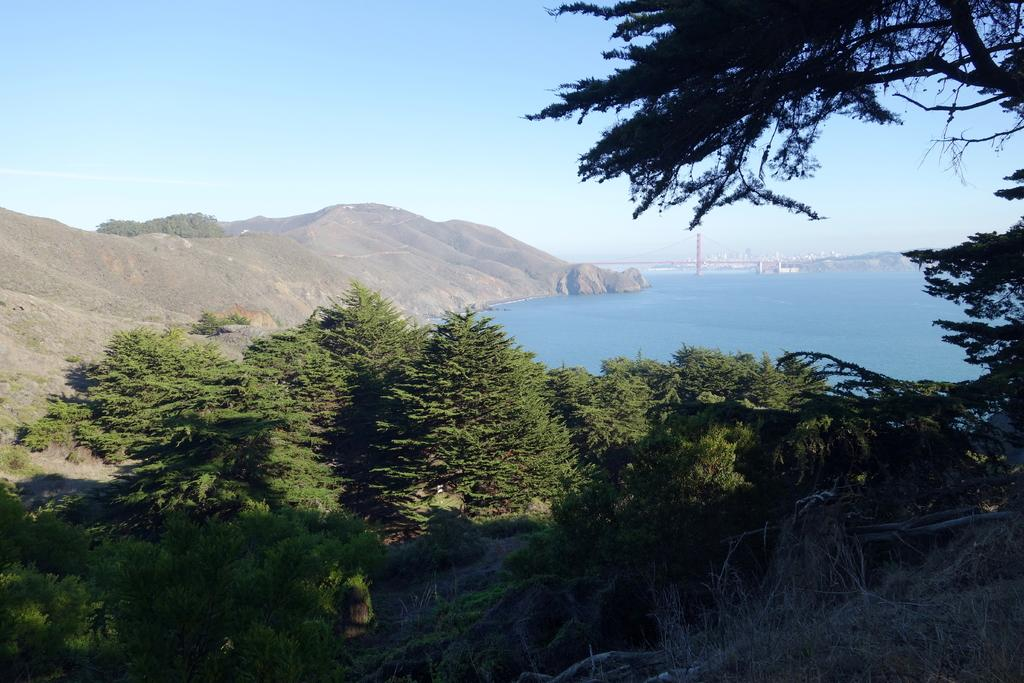What type of natural elements can be seen in the image? There are plants, trees, mountains, and an ocean visible in the image. What man-made structure is present in the image? There is a lighthouse in the image. What part of the natural environment is visible in the image? The sky is visible in the image. What type of error can be seen in the image? There is no error present in the image. Can you describe the appliance used to maintain the hall in the image? There is no hall or appliance present in the image. 